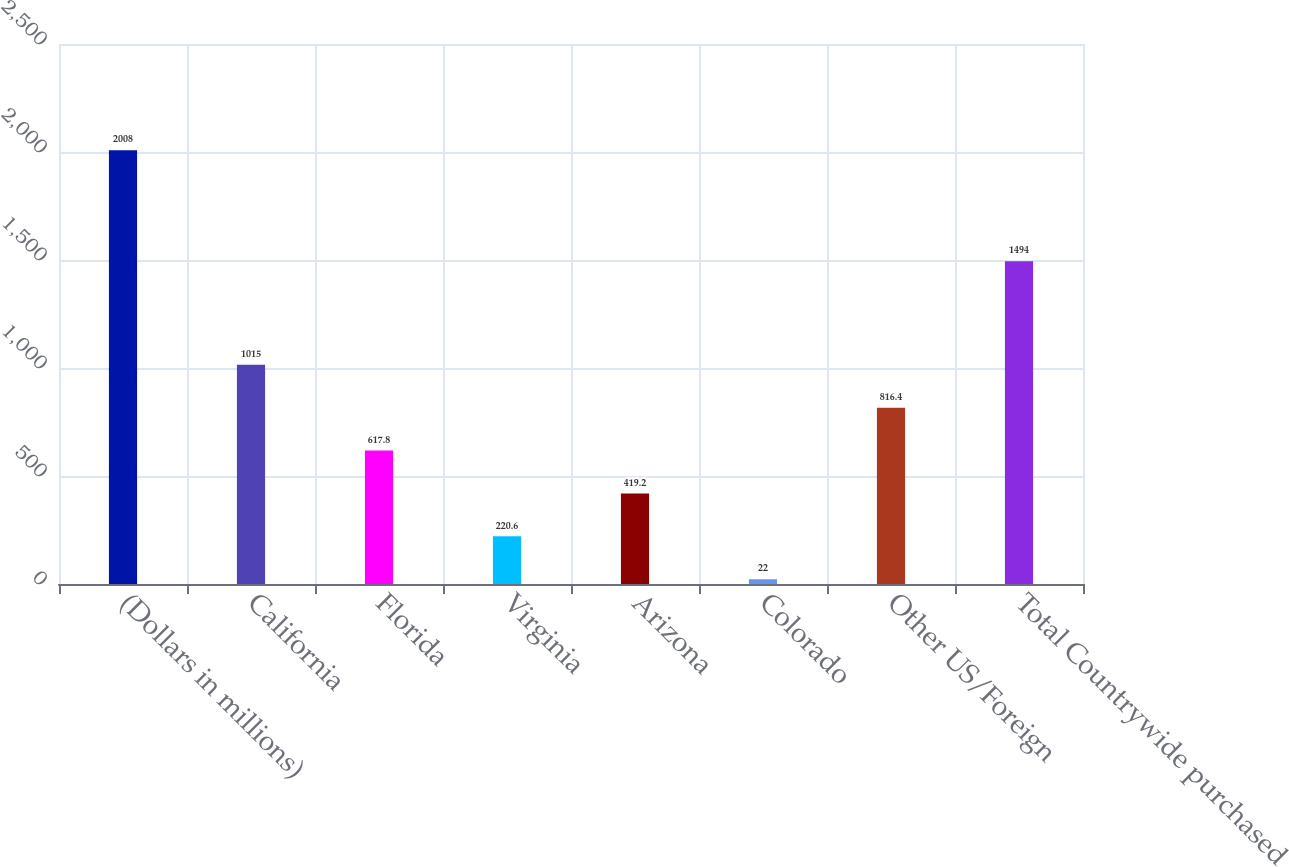<chart> <loc_0><loc_0><loc_500><loc_500><bar_chart><fcel>(Dollars in millions)<fcel>California<fcel>Florida<fcel>Virginia<fcel>Arizona<fcel>Colorado<fcel>Other US/Foreign<fcel>Total Countrywide purchased<nl><fcel>2008<fcel>1015<fcel>617.8<fcel>220.6<fcel>419.2<fcel>22<fcel>816.4<fcel>1494<nl></chart> 